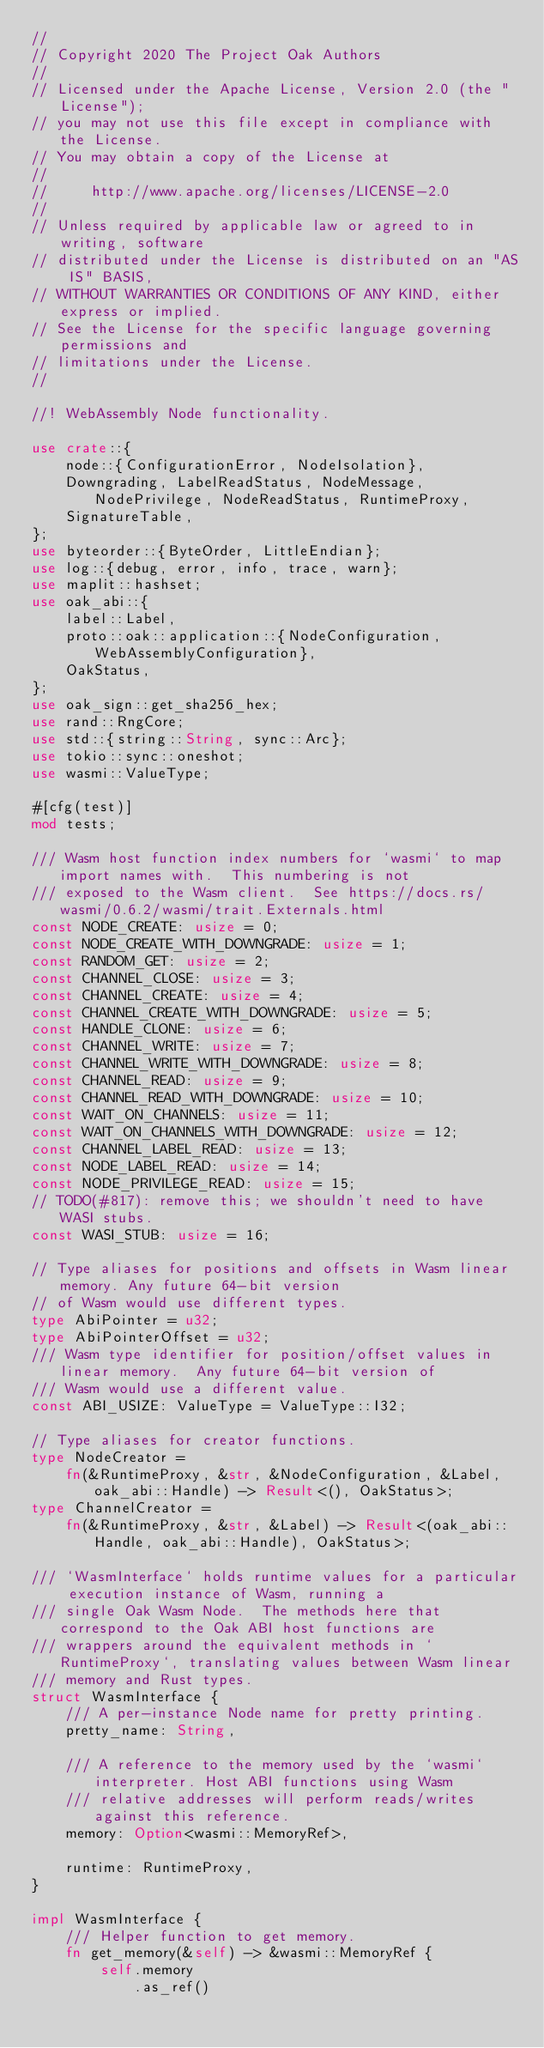Convert code to text. <code><loc_0><loc_0><loc_500><loc_500><_Rust_>//
// Copyright 2020 The Project Oak Authors
//
// Licensed under the Apache License, Version 2.0 (the "License");
// you may not use this file except in compliance with the License.
// You may obtain a copy of the License at
//
//     http://www.apache.org/licenses/LICENSE-2.0
//
// Unless required by applicable law or agreed to in writing, software
// distributed under the License is distributed on an "AS IS" BASIS,
// WITHOUT WARRANTIES OR CONDITIONS OF ANY KIND, either express or implied.
// See the License for the specific language governing permissions and
// limitations under the License.
//

//! WebAssembly Node functionality.

use crate::{
    node::{ConfigurationError, NodeIsolation},
    Downgrading, LabelReadStatus, NodeMessage, NodePrivilege, NodeReadStatus, RuntimeProxy,
    SignatureTable,
};
use byteorder::{ByteOrder, LittleEndian};
use log::{debug, error, info, trace, warn};
use maplit::hashset;
use oak_abi::{
    label::Label,
    proto::oak::application::{NodeConfiguration, WebAssemblyConfiguration},
    OakStatus,
};
use oak_sign::get_sha256_hex;
use rand::RngCore;
use std::{string::String, sync::Arc};
use tokio::sync::oneshot;
use wasmi::ValueType;

#[cfg(test)]
mod tests;

/// Wasm host function index numbers for `wasmi` to map import names with.  This numbering is not
/// exposed to the Wasm client.  See https://docs.rs/wasmi/0.6.2/wasmi/trait.Externals.html
const NODE_CREATE: usize = 0;
const NODE_CREATE_WITH_DOWNGRADE: usize = 1;
const RANDOM_GET: usize = 2;
const CHANNEL_CLOSE: usize = 3;
const CHANNEL_CREATE: usize = 4;
const CHANNEL_CREATE_WITH_DOWNGRADE: usize = 5;
const HANDLE_CLONE: usize = 6;
const CHANNEL_WRITE: usize = 7;
const CHANNEL_WRITE_WITH_DOWNGRADE: usize = 8;
const CHANNEL_READ: usize = 9;
const CHANNEL_READ_WITH_DOWNGRADE: usize = 10;
const WAIT_ON_CHANNELS: usize = 11;
const WAIT_ON_CHANNELS_WITH_DOWNGRADE: usize = 12;
const CHANNEL_LABEL_READ: usize = 13;
const NODE_LABEL_READ: usize = 14;
const NODE_PRIVILEGE_READ: usize = 15;
// TODO(#817): remove this; we shouldn't need to have WASI stubs.
const WASI_STUB: usize = 16;

// Type aliases for positions and offsets in Wasm linear memory. Any future 64-bit version
// of Wasm would use different types.
type AbiPointer = u32;
type AbiPointerOffset = u32;
/// Wasm type identifier for position/offset values in linear memory.  Any future 64-bit version of
/// Wasm would use a different value.
const ABI_USIZE: ValueType = ValueType::I32;

// Type aliases for creator functions.
type NodeCreator =
    fn(&RuntimeProxy, &str, &NodeConfiguration, &Label, oak_abi::Handle) -> Result<(), OakStatus>;
type ChannelCreator =
    fn(&RuntimeProxy, &str, &Label) -> Result<(oak_abi::Handle, oak_abi::Handle), OakStatus>;

/// `WasmInterface` holds runtime values for a particular execution instance of Wasm, running a
/// single Oak Wasm Node.  The methods here that correspond to the Oak ABI host functions are
/// wrappers around the equivalent methods in `RuntimeProxy`, translating values between Wasm linear
/// memory and Rust types.
struct WasmInterface {
    /// A per-instance Node name for pretty printing.
    pretty_name: String,

    /// A reference to the memory used by the `wasmi` interpreter. Host ABI functions using Wasm
    /// relative addresses will perform reads/writes against this reference.
    memory: Option<wasmi::MemoryRef>,

    runtime: RuntimeProxy,
}

impl WasmInterface {
    /// Helper function to get memory.
    fn get_memory(&self) -> &wasmi::MemoryRef {
        self.memory
            .as_ref()</code> 